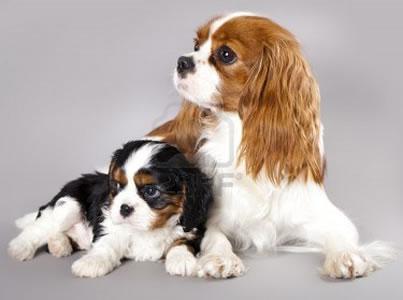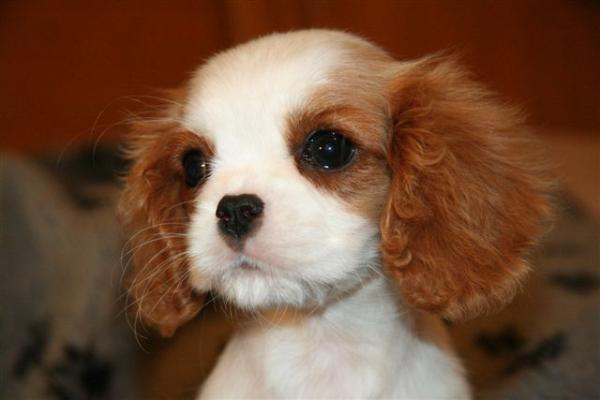The first image is the image on the left, the second image is the image on the right. Assess this claim about the two images: "One image features two animals, although one may not be a puppy, on a plain background.". Correct or not? Answer yes or no. Yes. The first image is the image on the left, the second image is the image on the right. Analyze the images presented: Is the assertion "An image shows a brown and white spaniel posed next to another animal." valid? Answer yes or no. Yes. 